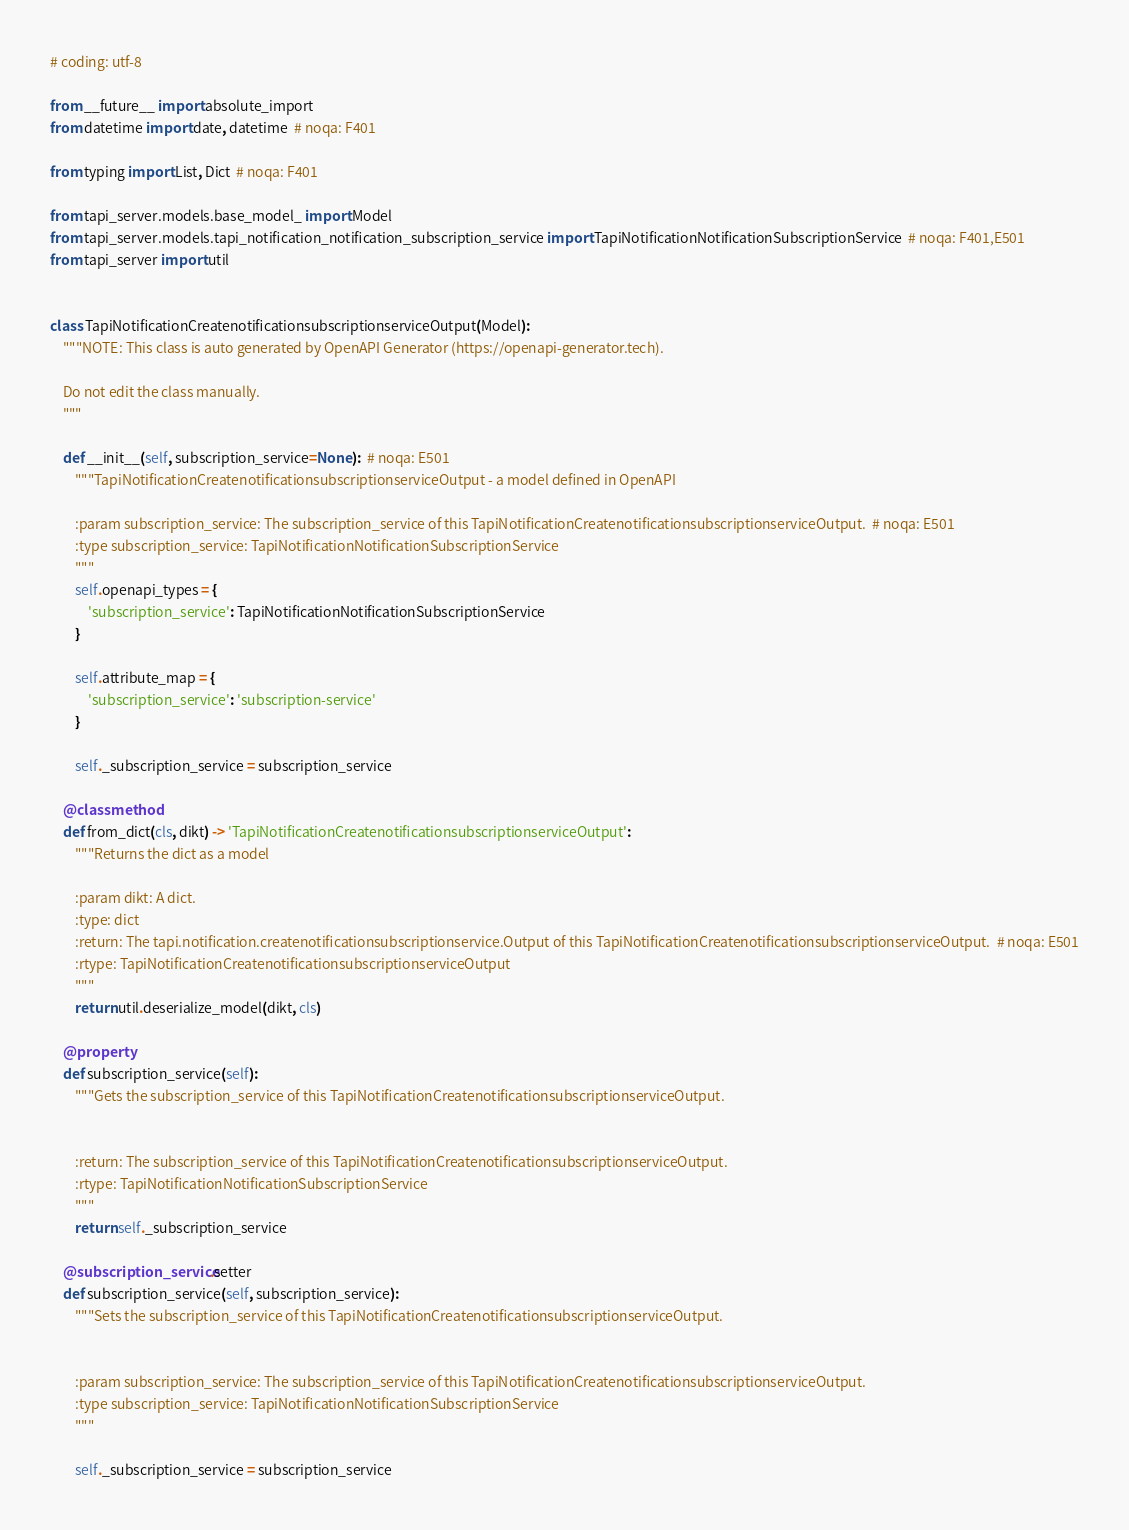<code> <loc_0><loc_0><loc_500><loc_500><_Python_># coding: utf-8

from __future__ import absolute_import
from datetime import date, datetime  # noqa: F401

from typing import List, Dict  # noqa: F401

from tapi_server.models.base_model_ import Model
from tapi_server.models.tapi_notification_notification_subscription_service import TapiNotificationNotificationSubscriptionService  # noqa: F401,E501
from tapi_server import util


class TapiNotificationCreatenotificationsubscriptionserviceOutput(Model):
    """NOTE: This class is auto generated by OpenAPI Generator (https://openapi-generator.tech).

    Do not edit the class manually.
    """

    def __init__(self, subscription_service=None):  # noqa: E501
        """TapiNotificationCreatenotificationsubscriptionserviceOutput - a model defined in OpenAPI

        :param subscription_service: The subscription_service of this TapiNotificationCreatenotificationsubscriptionserviceOutput.  # noqa: E501
        :type subscription_service: TapiNotificationNotificationSubscriptionService
        """
        self.openapi_types = {
            'subscription_service': TapiNotificationNotificationSubscriptionService
        }

        self.attribute_map = {
            'subscription_service': 'subscription-service'
        }

        self._subscription_service = subscription_service

    @classmethod
    def from_dict(cls, dikt) -> 'TapiNotificationCreatenotificationsubscriptionserviceOutput':
        """Returns the dict as a model

        :param dikt: A dict.
        :type: dict
        :return: The tapi.notification.createnotificationsubscriptionservice.Output of this TapiNotificationCreatenotificationsubscriptionserviceOutput.  # noqa: E501
        :rtype: TapiNotificationCreatenotificationsubscriptionserviceOutput
        """
        return util.deserialize_model(dikt, cls)

    @property
    def subscription_service(self):
        """Gets the subscription_service of this TapiNotificationCreatenotificationsubscriptionserviceOutput.


        :return: The subscription_service of this TapiNotificationCreatenotificationsubscriptionserviceOutput.
        :rtype: TapiNotificationNotificationSubscriptionService
        """
        return self._subscription_service

    @subscription_service.setter
    def subscription_service(self, subscription_service):
        """Sets the subscription_service of this TapiNotificationCreatenotificationsubscriptionserviceOutput.


        :param subscription_service: The subscription_service of this TapiNotificationCreatenotificationsubscriptionserviceOutput.
        :type subscription_service: TapiNotificationNotificationSubscriptionService
        """

        self._subscription_service = subscription_service
</code> 